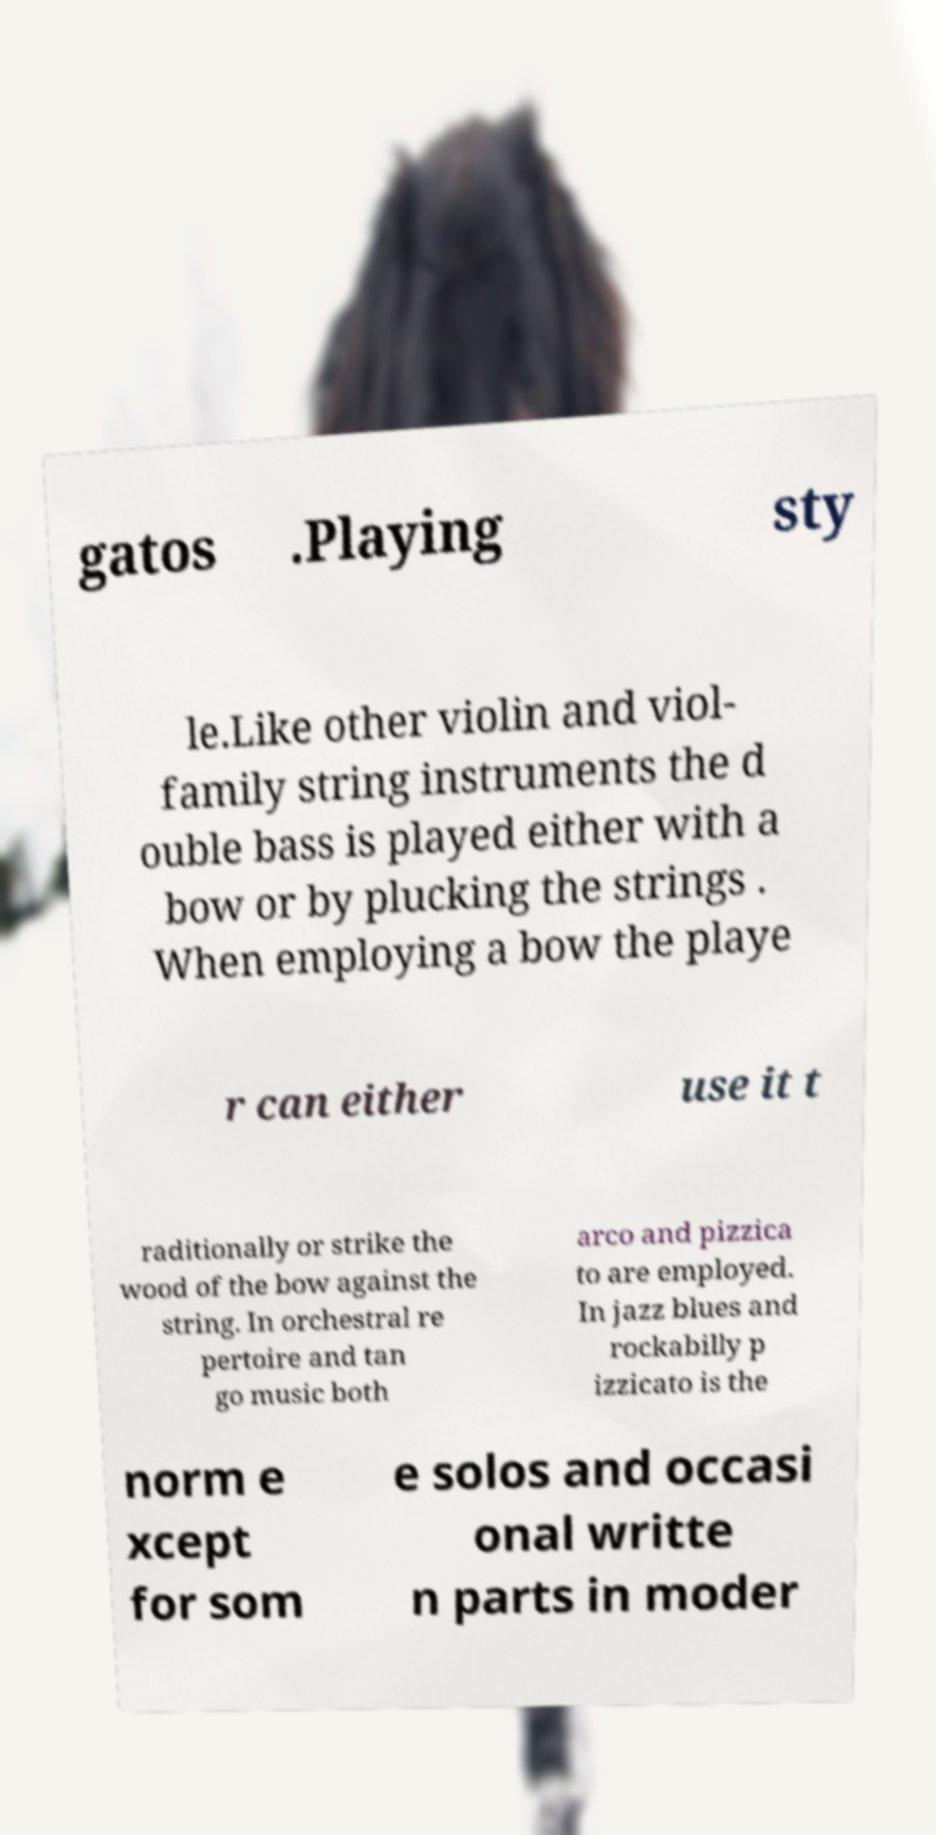Can you read and provide the text displayed in the image?This photo seems to have some interesting text. Can you extract and type it out for me? gatos .Playing sty le.Like other violin and viol- family string instruments the d ouble bass is played either with a bow or by plucking the strings . When employing a bow the playe r can either use it t raditionally or strike the wood of the bow against the string. In orchestral re pertoire and tan go music both arco and pizzica to are employed. In jazz blues and rockabilly p izzicato is the norm e xcept for som e solos and occasi onal writte n parts in moder 